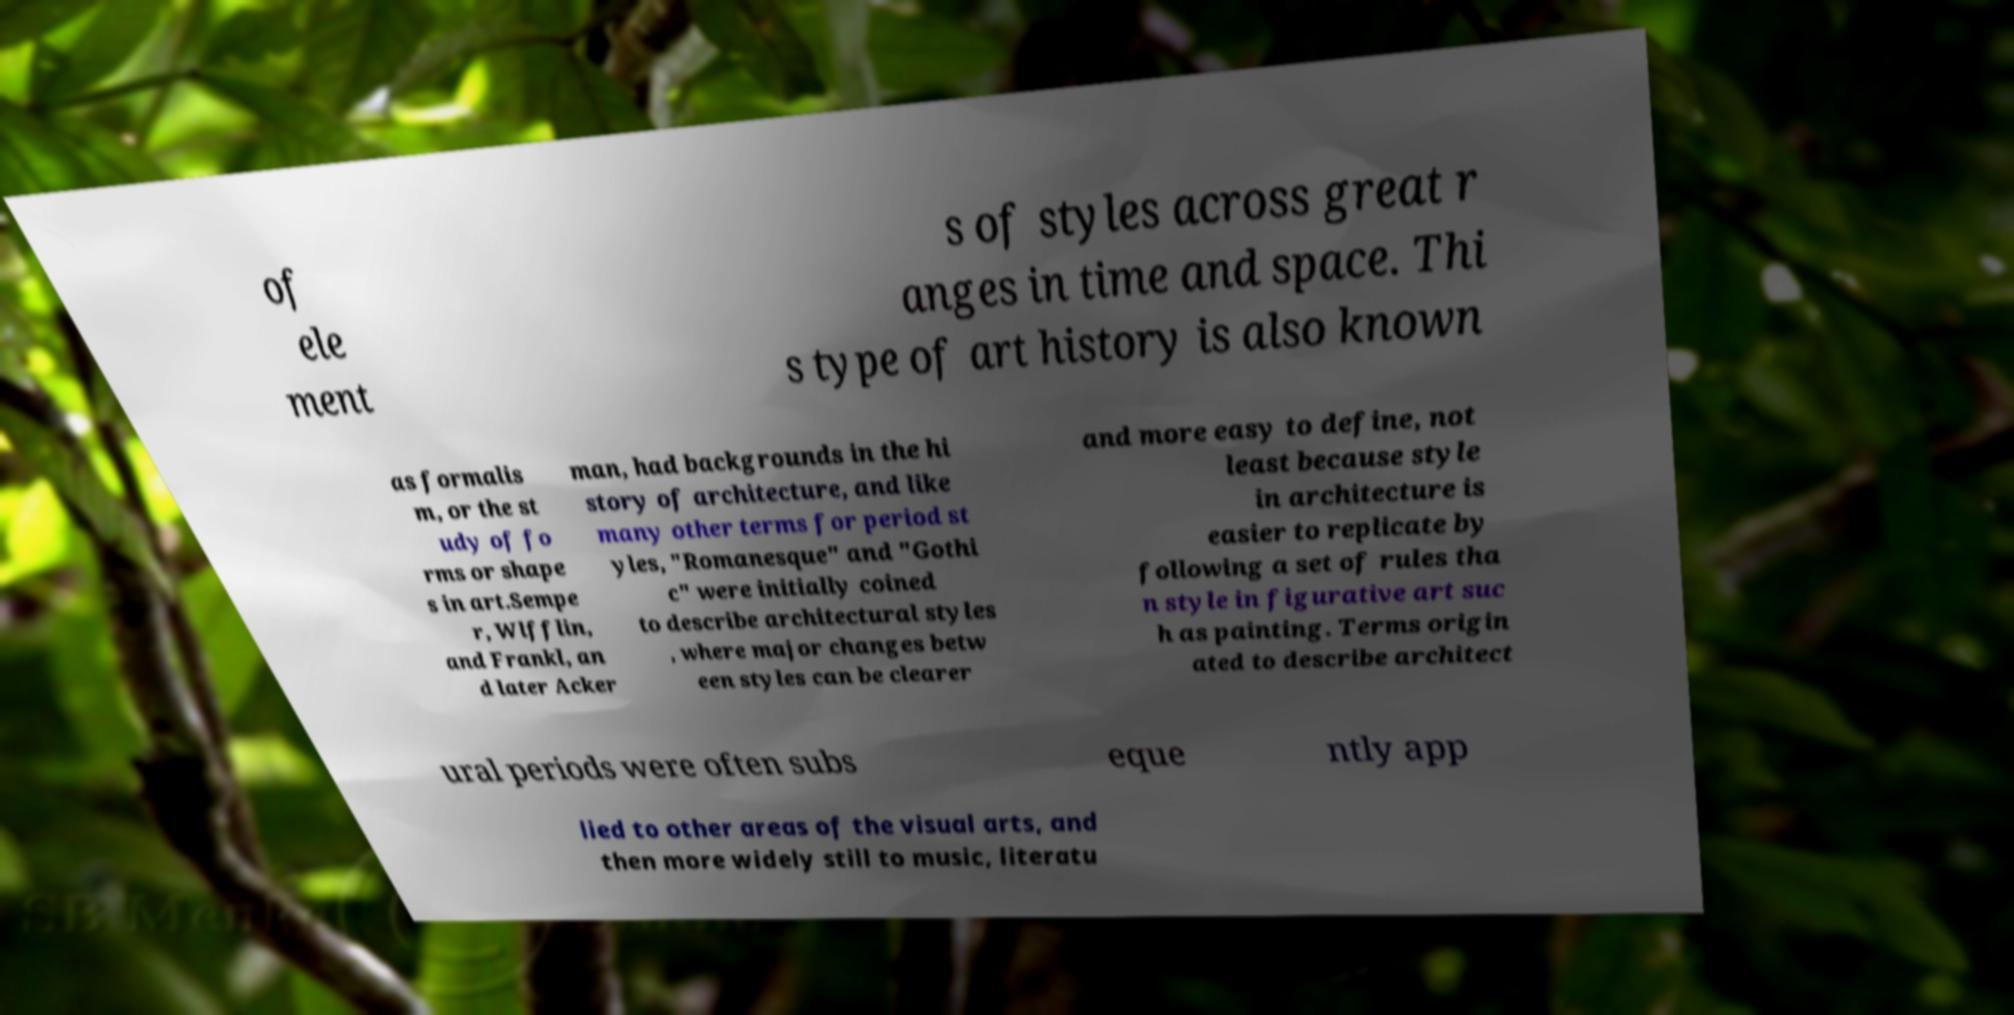Could you extract and type out the text from this image? of ele ment s of styles across great r anges in time and space. Thi s type of art history is also known as formalis m, or the st udy of fo rms or shape s in art.Sempe r, Wlfflin, and Frankl, an d later Acker man, had backgrounds in the hi story of architecture, and like many other terms for period st yles, "Romanesque" and "Gothi c" were initially coined to describe architectural styles , where major changes betw een styles can be clearer and more easy to define, not least because style in architecture is easier to replicate by following a set of rules tha n style in figurative art suc h as painting. Terms origin ated to describe architect ural periods were often subs eque ntly app lied to other areas of the visual arts, and then more widely still to music, literatu 